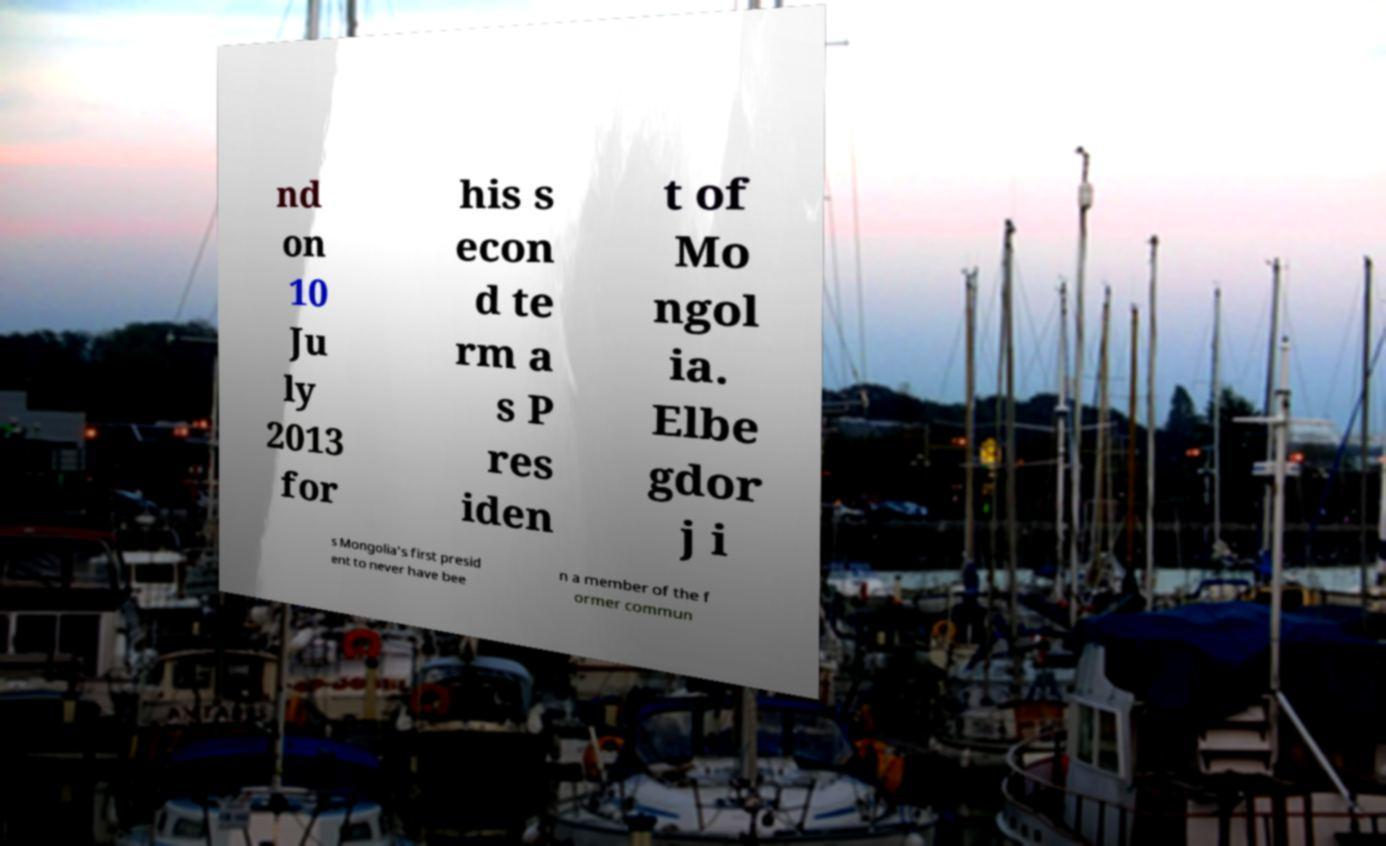Please read and relay the text visible in this image. What does it say? nd on 10 Ju ly 2013 for his s econ d te rm a s P res iden t of Mo ngol ia. Elbe gdor j i s Mongolia's first presid ent to never have bee n a member of the f ormer commun 